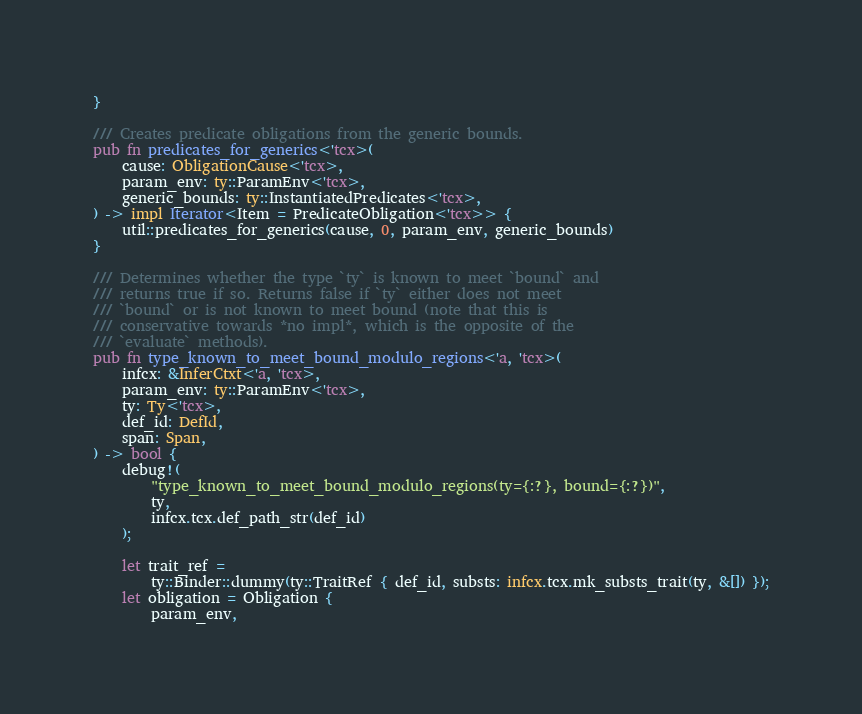<code> <loc_0><loc_0><loc_500><loc_500><_Rust_>}

/// Creates predicate obligations from the generic bounds.
pub fn predicates_for_generics<'tcx>(
    cause: ObligationCause<'tcx>,
    param_env: ty::ParamEnv<'tcx>,
    generic_bounds: ty::InstantiatedPredicates<'tcx>,
) -> impl Iterator<Item = PredicateObligation<'tcx>> {
    util::predicates_for_generics(cause, 0, param_env, generic_bounds)
}

/// Determines whether the type `ty` is known to meet `bound` and
/// returns true if so. Returns false if `ty` either does not meet
/// `bound` or is not known to meet bound (note that this is
/// conservative towards *no impl*, which is the opposite of the
/// `evaluate` methods).
pub fn type_known_to_meet_bound_modulo_regions<'a, 'tcx>(
    infcx: &InferCtxt<'a, 'tcx>,
    param_env: ty::ParamEnv<'tcx>,
    ty: Ty<'tcx>,
    def_id: DefId,
    span: Span,
) -> bool {
    debug!(
        "type_known_to_meet_bound_modulo_regions(ty={:?}, bound={:?})",
        ty,
        infcx.tcx.def_path_str(def_id)
    );

    let trait_ref =
        ty::Binder::dummy(ty::TraitRef { def_id, substs: infcx.tcx.mk_substs_trait(ty, &[]) });
    let obligation = Obligation {
        param_env,</code> 